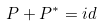Convert formula to latex. <formula><loc_0><loc_0><loc_500><loc_500>P + P ^ { * } = i d</formula> 